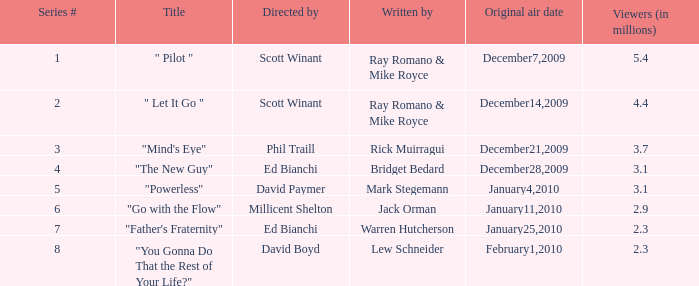When did the episode  "you gonna do that the rest of your life?" air? February1,2010. 